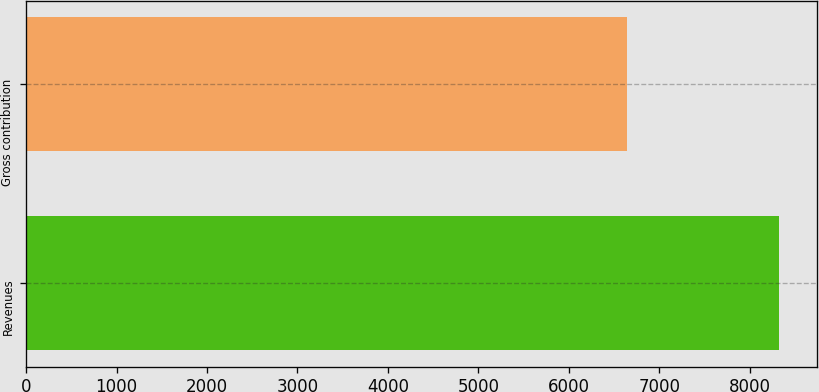Convert chart. <chart><loc_0><loc_0><loc_500><loc_500><bar_chart><fcel>Revenues<fcel>Gross contribution<nl><fcel>8324<fcel>6639<nl></chart> 